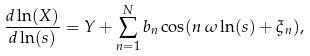Convert formula to latex. <formula><loc_0><loc_0><loc_500><loc_500>\frac { d \ln ( X ) } { d \ln ( s ) } = Y + \sum _ { n = 1 } ^ { N } b _ { n } \cos ( n \, \omega \ln ( s ) + \xi _ { n } ) ,</formula> 